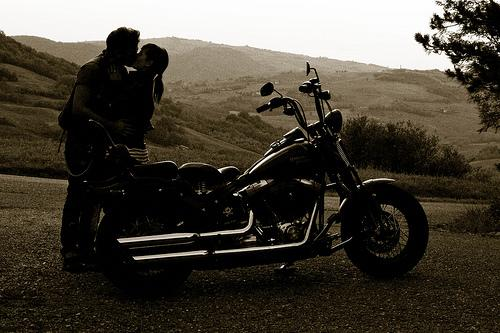How many exhaust pipes are visible on the motorcycle, and what is their appearance like? There are two shiny chrome motorcycle exhaust pipes that are reflective. Describe the state of the road and its surroundings in the image. The road is bare, with gravel on the ground, a thin tree behind it, and large hills in the background. In the image, what type of hairstyle does the woman have, and what is she wearing? The woman has a ponytail and is wearing a striped black and white skirt. Provide a description of the couple in the image. A man and woman are kissing and embracing by a motorcycle, with the woman's ponytail and the man's jeans visible. Describe the landscape in the background of the image. There is a mountain range and a leafy tree, with the sky being grey and overcast. Mention two objects that are associated with the motorcycle and describe their position. The motorcycle has two mirrors on top of the handlebars and one front headlight below the handlebars. What is the dominant sentiment in the image, based on the couple and the surroundings? The dominant sentiment is a romantic and adventurous atmosphere, with the couple embracing and the motorcycle and mountainous landscape in the background. Are the couple in the image interacting with each other or with the motorcycle? The couple is interacting with each other, embracing and kissing. What is the primary vehicle in the image and what color is it? The primary vehicle is a black and chrome motorcycle. What are the clothing items worn by the man in the image, and mention an accessory he has. The man is wearing a jacket, jeans, and has a chain on his leg. 